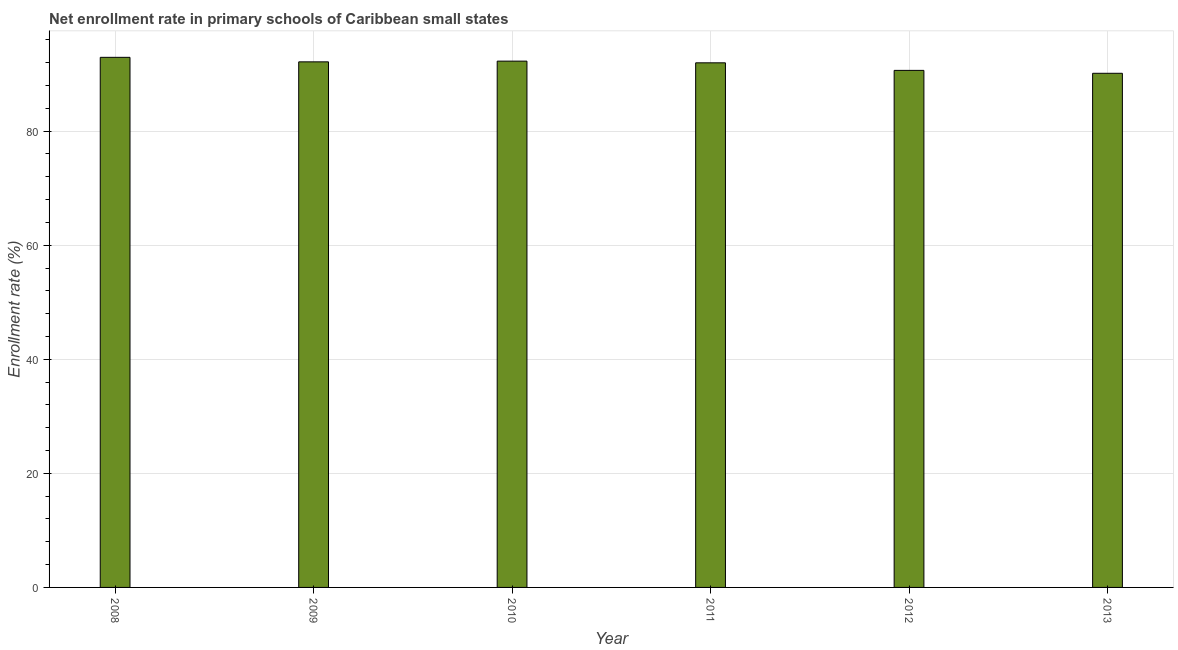Does the graph contain grids?
Ensure brevity in your answer.  Yes. What is the title of the graph?
Offer a terse response. Net enrollment rate in primary schools of Caribbean small states. What is the label or title of the Y-axis?
Provide a succinct answer. Enrollment rate (%). What is the net enrollment rate in primary schools in 2008?
Offer a very short reply. 92.94. Across all years, what is the maximum net enrollment rate in primary schools?
Provide a succinct answer. 92.94. Across all years, what is the minimum net enrollment rate in primary schools?
Make the answer very short. 90.14. In which year was the net enrollment rate in primary schools maximum?
Ensure brevity in your answer.  2008. What is the sum of the net enrollment rate in primary schools?
Offer a very short reply. 550.11. What is the difference between the net enrollment rate in primary schools in 2008 and 2009?
Offer a very short reply. 0.79. What is the average net enrollment rate in primary schools per year?
Your response must be concise. 91.69. What is the median net enrollment rate in primary schools?
Ensure brevity in your answer.  92.06. In how many years, is the net enrollment rate in primary schools greater than 92 %?
Provide a succinct answer. 3. Is the difference between the net enrollment rate in primary schools in 2011 and 2013 greater than the difference between any two years?
Offer a very short reply. No. What is the difference between the highest and the second highest net enrollment rate in primary schools?
Make the answer very short. 0.67. In how many years, is the net enrollment rate in primary schools greater than the average net enrollment rate in primary schools taken over all years?
Make the answer very short. 4. How many bars are there?
Make the answer very short. 6. Are all the bars in the graph horizontal?
Keep it short and to the point. No. What is the difference between two consecutive major ticks on the Y-axis?
Your response must be concise. 20. Are the values on the major ticks of Y-axis written in scientific E-notation?
Offer a terse response. No. What is the Enrollment rate (%) of 2008?
Keep it short and to the point. 92.94. What is the Enrollment rate (%) of 2009?
Offer a very short reply. 92.14. What is the Enrollment rate (%) in 2010?
Make the answer very short. 92.27. What is the Enrollment rate (%) of 2011?
Provide a succinct answer. 91.97. What is the Enrollment rate (%) in 2012?
Ensure brevity in your answer.  90.65. What is the Enrollment rate (%) of 2013?
Offer a terse response. 90.14. What is the difference between the Enrollment rate (%) in 2008 and 2009?
Make the answer very short. 0.79. What is the difference between the Enrollment rate (%) in 2008 and 2010?
Ensure brevity in your answer.  0.67. What is the difference between the Enrollment rate (%) in 2008 and 2011?
Ensure brevity in your answer.  0.96. What is the difference between the Enrollment rate (%) in 2008 and 2012?
Ensure brevity in your answer.  2.29. What is the difference between the Enrollment rate (%) in 2008 and 2013?
Make the answer very short. 2.8. What is the difference between the Enrollment rate (%) in 2009 and 2010?
Offer a terse response. -0.13. What is the difference between the Enrollment rate (%) in 2009 and 2011?
Keep it short and to the point. 0.17. What is the difference between the Enrollment rate (%) in 2009 and 2012?
Your answer should be compact. 1.5. What is the difference between the Enrollment rate (%) in 2009 and 2013?
Your response must be concise. 2.01. What is the difference between the Enrollment rate (%) in 2010 and 2011?
Your answer should be very brief. 0.3. What is the difference between the Enrollment rate (%) in 2010 and 2012?
Your answer should be compact. 1.62. What is the difference between the Enrollment rate (%) in 2010 and 2013?
Your answer should be very brief. 2.13. What is the difference between the Enrollment rate (%) in 2011 and 2012?
Provide a short and direct response. 1.33. What is the difference between the Enrollment rate (%) in 2011 and 2013?
Offer a very short reply. 1.84. What is the difference between the Enrollment rate (%) in 2012 and 2013?
Offer a terse response. 0.51. What is the ratio of the Enrollment rate (%) in 2008 to that in 2010?
Ensure brevity in your answer.  1.01. What is the ratio of the Enrollment rate (%) in 2008 to that in 2011?
Your answer should be compact. 1.01. What is the ratio of the Enrollment rate (%) in 2008 to that in 2013?
Your answer should be compact. 1.03. What is the ratio of the Enrollment rate (%) in 2009 to that in 2010?
Provide a succinct answer. 1. What is the ratio of the Enrollment rate (%) in 2009 to that in 2011?
Keep it short and to the point. 1. What is the ratio of the Enrollment rate (%) in 2009 to that in 2012?
Offer a terse response. 1.02. 